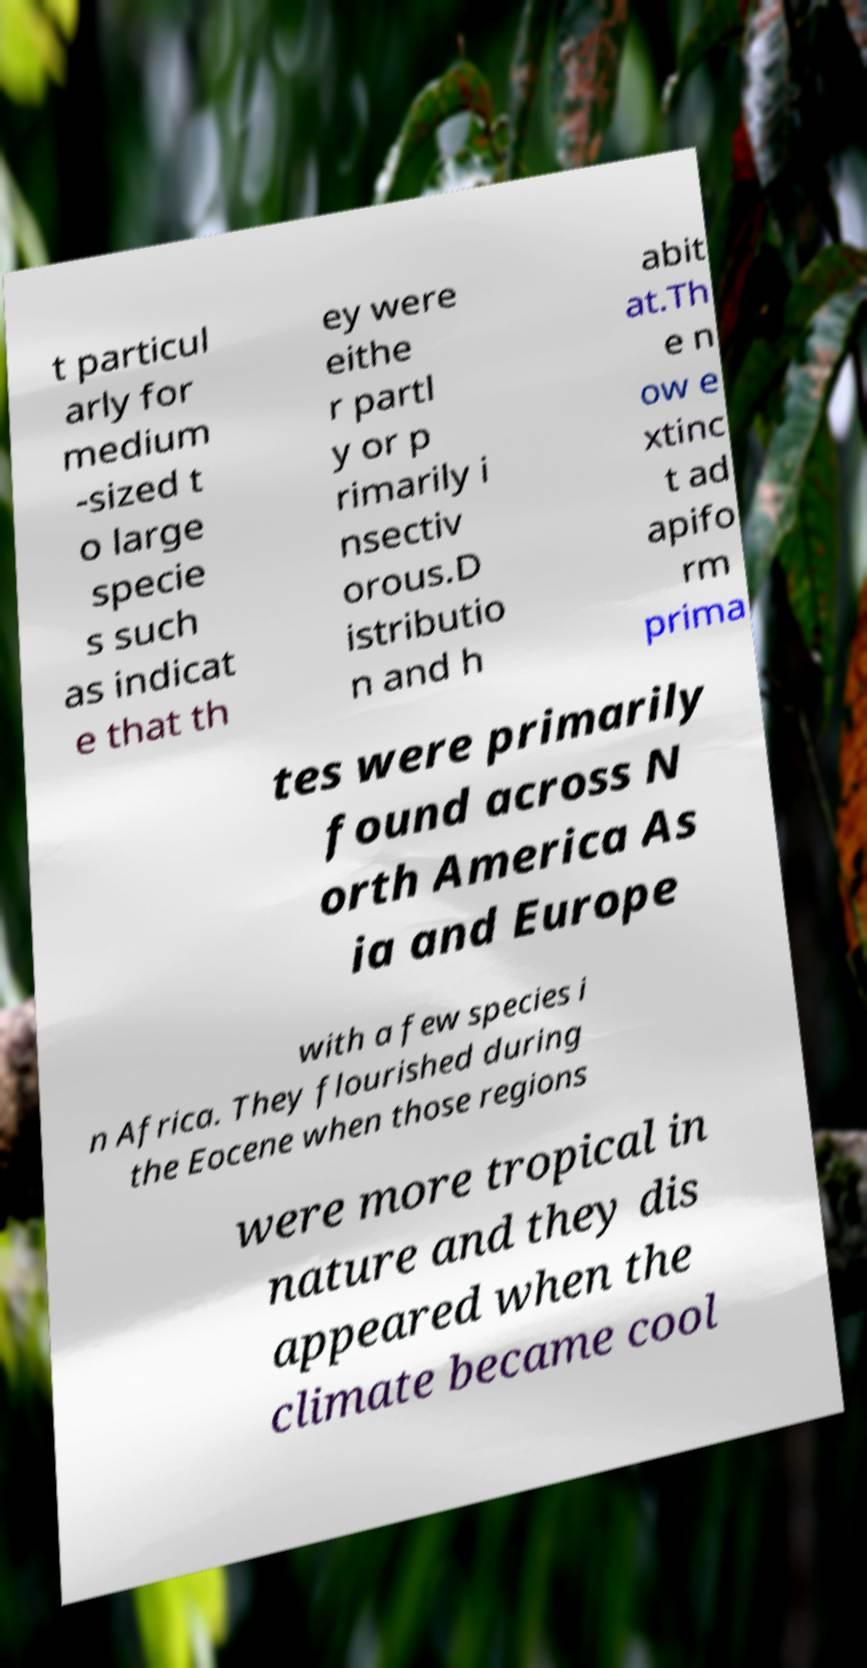I need the written content from this picture converted into text. Can you do that? t particul arly for medium -sized t o large specie s such as indicat e that th ey were eithe r partl y or p rimarily i nsectiv orous.D istributio n and h abit at.Th e n ow e xtinc t ad apifo rm prima tes were primarily found across N orth America As ia and Europe with a few species i n Africa. They flourished during the Eocene when those regions were more tropical in nature and they dis appeared when the climate became cool 